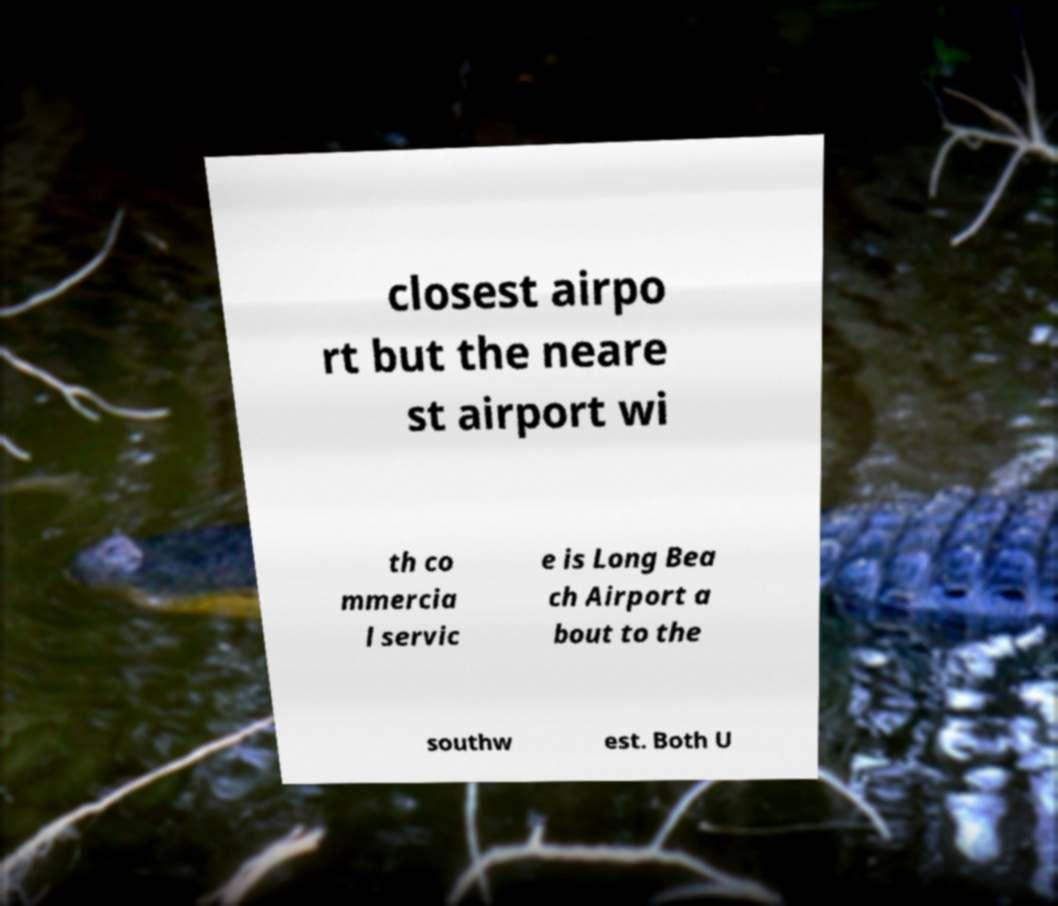Please identify and transcribe the text found in this image. closest airpo rt but the neare st airport wi th co mmercia l servic e is Long Bea ch Airport a bout to the southw est. Both U 